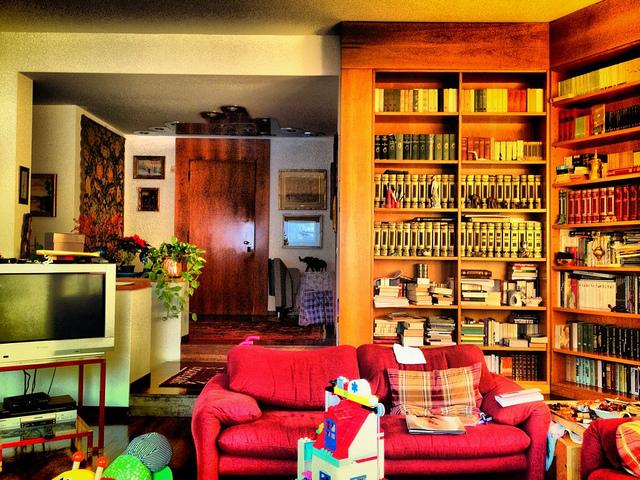What room was photographed with the built-in book case?
Quick response, please. Living room. Where is the encyclopedias?
Quick response, please. On shelves. What color is the couch?
Quick response, please. Red. 